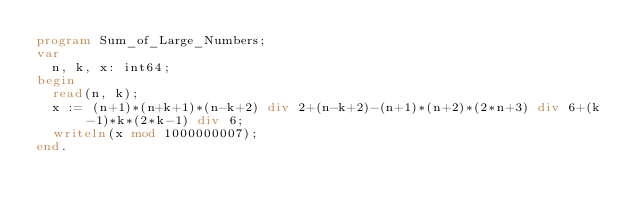<code> <loc_0><loc_0><loc_500><loc_500><_Pascal_>program Sum_of_Large_Numbers;
var
  n, k, x: int64;
begin
  read(n, k);
  x := (n+1)*(n+k+1)*(n-k+2) div 2+(n-k+2)-(n+1)*(n+2)*(2*n+3) div 6+(k-1)*k*(2*k-1) div 6;
  writeln(x mod 1000000007);
end.</code> 